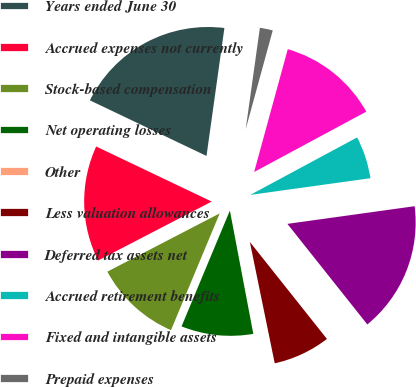Convert chart. <chart><loc_0><loc_0><loc_500><loc_500><pie_chart><fcel>Years ended June 30<fcel>Accrued expenses not currently<fcel>Stock-based compensation<fcel>Net operating losses<fcel>Other<fcel>Less valuation allowances<fcel>Deferred tax assets net<fcel>Accrued retirement benefits<fcel>Fixed and intangible assets<fcel>Prepaid expenses<nl><fcel>20.13%<fcel>14.7%<fcel>11.09%<fcel>9.28%<fcel>0.23%<fcel>7.47%<fcel>16.51%<fcel>5.66%<fcel>12.89%<fcel>2.04%<nl></chart> 